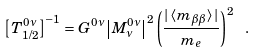Convert formula to latex. <formula><loc_0><loc_0><loc_500><loc_500>\left [ T ^ { 0 \nu } _ { 1 / 2 } \right ] ^ { - 1 } = G ^ { 0 \nu } \left | M ^ { 0 \nu } _ { \nu } \right | ^ { 2 } \left ( \frac { | \left < m _ { \beta \beta } \right > | } { m _ { e } } \right ) ^ { 2 } \ .</formula> 